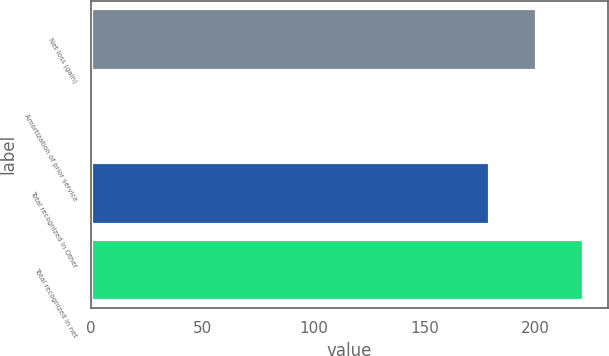<chart> <loc_0><loc_0><loc_500><loc_500><bar_chart><fcel>Net loss (gain)<fcel>Amortization of prior service<fcel>Total recognized in Other<fcel>Total recognized in net<nl><fcel>200.1<fcel>1<fcel>179<fcel>221.2<nl></chart> 